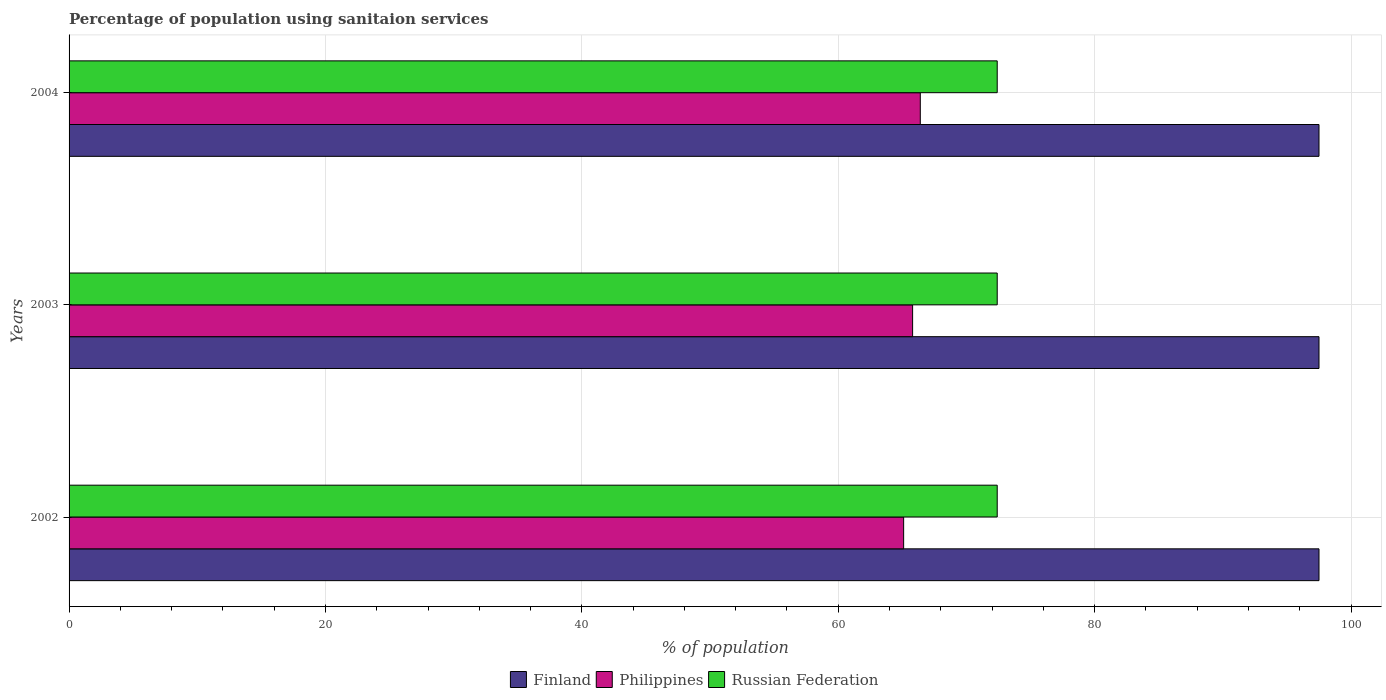How many different coloured bars are there?
Offer a terse response. 3. Are the number of bars per tick equal to the number of legend labels?
Provide a short and direct response. Yes. How many bars are there on the 2nd tick from the top?
Offer a terse response. 3. What is the label of the 1st group of bars from the top?
Provide a succinct answer. 2004. What is the percentage of population using sanitaion services in Finland in 2002?
Your answer should be very brief. 97.5. Across all years, what is the maximum percentage of population using sanitaion services in Philippines?
Provide a short and direct response. 66.4. Across all years, what is the minimum percentage of population using sanitaion services in Russian Federation?
Your answer should be compact. 72.4. In which year was the percentage of population using sanitaion services in Finland minimum?
Keep it short and to the point. 2002. What is the total percentage of population using sanitaion services in Finland in the graph?
Keep it short and to the point. 292.5. What is the difference between the percentage of population using sanitaion services in Philippines in 2004 and the percentage of population using sanitaion services in Finland in 2003?
Keep it short and to the point. -31.1. What is the average percentage of population using sanitaion services in Russian Federation per year?
Make the answer very short. 72.4. In the year 2003, what is the difference between the percentage of population using sanitaion services in Finland and percentage of population using sanitaion services in Russian Federation?
Offer a terse response. 25.1. In how many years, is the percentage of population using sanitaion services in Russian Federation greater than 44 %?
Offer a terse response. 3. What is the ratio of the percentage of population using sanitaion services in Philippines in 2002 to that in 2003?
Your answer should be compact. 0.99. Is the percentage of population using sanitaion services in Finland in 2002 less than that in 2004?
Your answer should be very brief. No. What is the difference between the highest and the second highest percentage of population using sanitaion services in Philippines?
Your answer should be compact. 0.6. Is the sum of the percentage of population using sanitaion services in Russian Federation in 2003 and 2004 greater than the maximum percentage of population using sanitaion services in Finland across all years?
Your response must be concise. Yes. What does the 3rd bar from the top in 2002 represents?
Offer a terse response. Finland. What does the 3rd bar from the bottom in 2003 represents?
Provide a short and direct response. Russian Federation. Is it the case that in every year, the sum of the percentage of population using sanitaion services in Philippines and percentage of population using sanitaion services in Russian Federation is greater than the percentage of population using sanitaion services in Finland?
Keep it short and to the point. Yes. How many bars are there?
Ensure brevity in your answer.  9. Where does the legend appear in the graph?
Provide a short and direct response. Bottom center. How are the legend labels stacked?
Provide a succinct answer. Horizontal. What is the title of the graph?
Make the answer very short. Percentage of population using sanitaion services. What is the label or title of the X-axis?
Make the answer very short. % of population. What is the label or title of the Y-axis?
Keep it short and to the point. Years. What is the % of population in Finland in 2002?
Make the answer very short. 97.5. What is the % of population of Philippines in 2002?
Provide a succinct answer. 65.1. What is the % of population of Russian Federation in 2002?
Your response must be concise. 72.4. What is the % of population of Finland in 2003?
Your response must be concise. 97.5. What is the % of population of Philippines in 2003?
Provide a succinct answer. 65.8. What is the % of population in Russian Federation in 2003?
Offer a very short reply. 72.4. What is the % of population in Finland in 2004?
Offer a very short reply. 97.5. What is the % of population of Philippines in 2004?
Offer a terse response. 66.4. What is the % of population in Russian Federation in 2004?
Keep it short and to the point. 72.4. Across all years, what is the maximum % of population of Finland?
Your answer should be compact. 97.5. Across all years, what is the maximum % of population of Philippines?
Provide a succinct answer. 66.4. Across all years, what is the maximum % of population of Russian Federation?
Offer a very short reply. 72.4. Across all years, what is the minimum % of population of Finland?
Provide a short and direct response. 97.5. Across all years, what is the minimum % of population in Philippines?
Make the answer very short. 65.1. Across all years, what is the minimum % of population of Russian Federation?
Provide a short and direct response. 72.4. What is the total % of population of Finland in the graph?
Your answer should be very brief. 292.5. What is the total % of population of Philippines in the graph?
Provide a short and direct response. 197.3. What is the total % of population of Russian Federation in the graph?
Provide a succinct answer. 217.2. What is the difference between the % of population in Philippines in 2002 and that in 2003?
Provide a short and direct response. -0.7. What is the difference between the % of population in Finland in 2002 and that in 2004?
Your response must be concise. 0. What is the difference between the % of population of Philippines in 2002 and that in 2004?
Offer a terse response. -1.3. What is the difference between the % of population in Russian Federation in 2003 and that in 2004?
Your answer should be compact. 0. What is the difference between the % of population in Finland in 2002 and the % of population in Philippines in 2003?
Offer a terse response. 31.7. What is the difference between the % of population of Finland in 2002 and the % of population of Russian Federation in 2003?
Offer a very short reply. 25.1. What is the difference between the % of population of Finland in 2002 and the % of population of Philippines in 2004?
Ensure brevity in your answer.  31.1. What is the difference between the % of population of Finland in 2002 and the % of population of Russian Federation in 2004?
Your answer should be very brief. 25.1. What is the difference between the % of population in Finland in 2003 and the % of population in Philippines in 2004?
Your answer should be very brief. 31.1. What is the difference between the % of population of Finland in 2003 and the % of population of Russian Federation in 2004?
Offer a terse response. 25.1. What is the difference between the % of population of Philippines in 2003 and the % of population of Russian Federation in 2004?
Your response must be concise. -6.6. What is the average % of population in Finland per year?
Your answer should be very brief. 97.5. What is the average % of population of Philippines per year?
Keep it short and to the point. 65.77. What is the average % of population of Russian Federation per year?
Your answer should be very brief. 72.4. In the year 2002, what is the difference between the % of population in Finland and % of population in Philippines?
Offer a terse response. 32.4. In the year 2002, what is the difference between the % of population in Finland and % of population in Russian Federation?
Keep it short and to the point. 25.1. In the year 2003, what is the difference between the % of population of Finland and % of population of Philippines?
Give a very brief answer. 31.7. In the year 2003, what is the difference between the % of population of Finland and % of population of Russian Federation?
Your response must be concise. 25.1. In the year 2003, what is the difference between the % of population of Philippines and % of population of Russian Federation?
Provide a short and direct response. -6.6. In the year 2004, what is the difference between the % of population in Finland and % of population in Philippines?
Keep it short and to the point. 31.1. In the year 2004, what is the difference between the % of population in Finland and % of population in Russian Federation?
Give a very brief answer. 25.1. What is the ratio of the % of population of Finland in 2002 to that in 2003?
Provide a short and direct response. 1. What is the ratio of the % of population of Philippines in 2002 to that in 2003?
Make the answer very short. 0.99. What is the ratio of the % of population in Finland in 2002 to that in 2004?
Ensure brevity in your answer.  1. What is the ratio of the % of population of Philippines in 2002 to that in 2004?
Your answer should be very brief. 0.98. What is the ratio of the % of population in Russian Federation in 2002 to that in 2004?
Provide a succinct answer. 1. What is the ratio of the % of population in Russian Federation in 2003 to that in 2004?
Your answer should be very brief. 1. What is the difference between the highest and the second highest % of population in Philippines?
Provide a succinct answer. 0.6. What is the difference between the highest and the second highest % of population of Russian Federation?
Your answer should be very brief. 0. What is the difference between the highest and the lowest % of population of Philippines?
Give a very brief answer. 1.3. What is the difference between the highest and the lowest % of population of Russian Federation?
Keep it short and to the point. 0. 